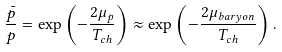Convert formula to latex. <formula><loc_0><loc_0><loc_500><loc_500>\frac { \bar { p } } { p } = \exp \left ( - \frac { 2 \mu _ { p } } { T _ { c h } } \right ) \approx \exp \left ( - \frac { 2 \mu _ { b a r y o n } } { T _ { c h } } \right ) .</formula> 